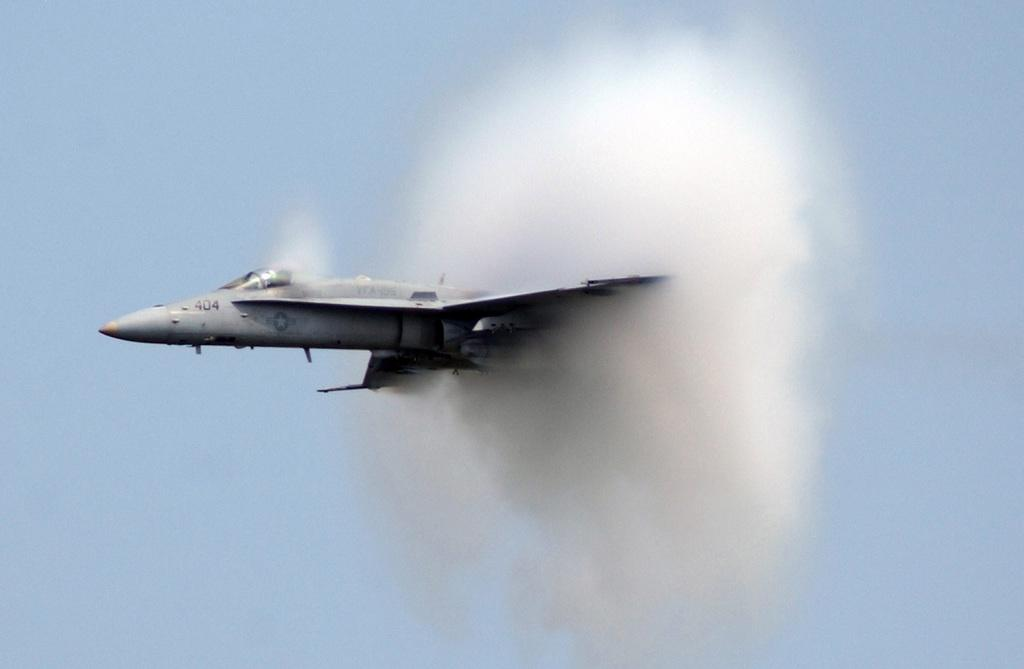<image>
Summarize the visual content of the image. a military jet with 404 on the nose cone flies through a cloud 